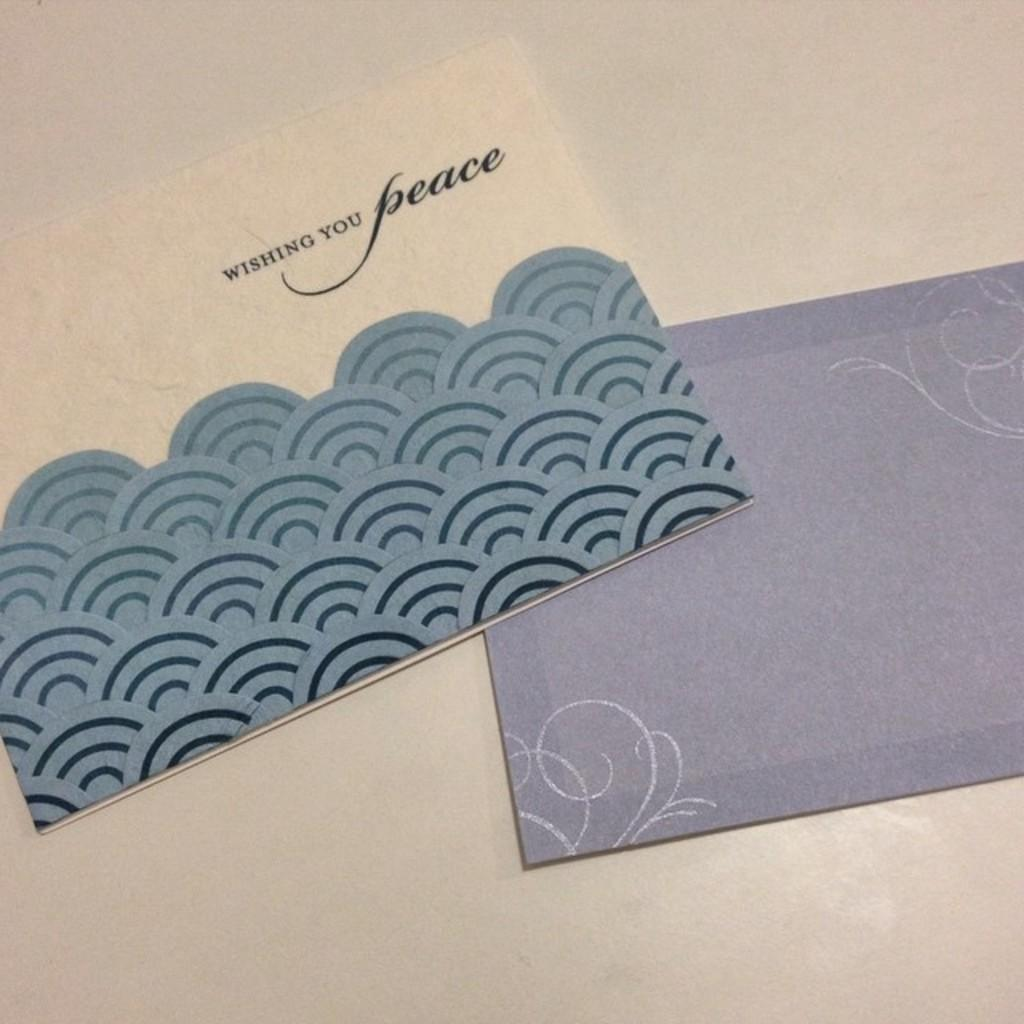<image>
Describe the image concisely. A greeting card with a blue wave design that says wishing you peace 